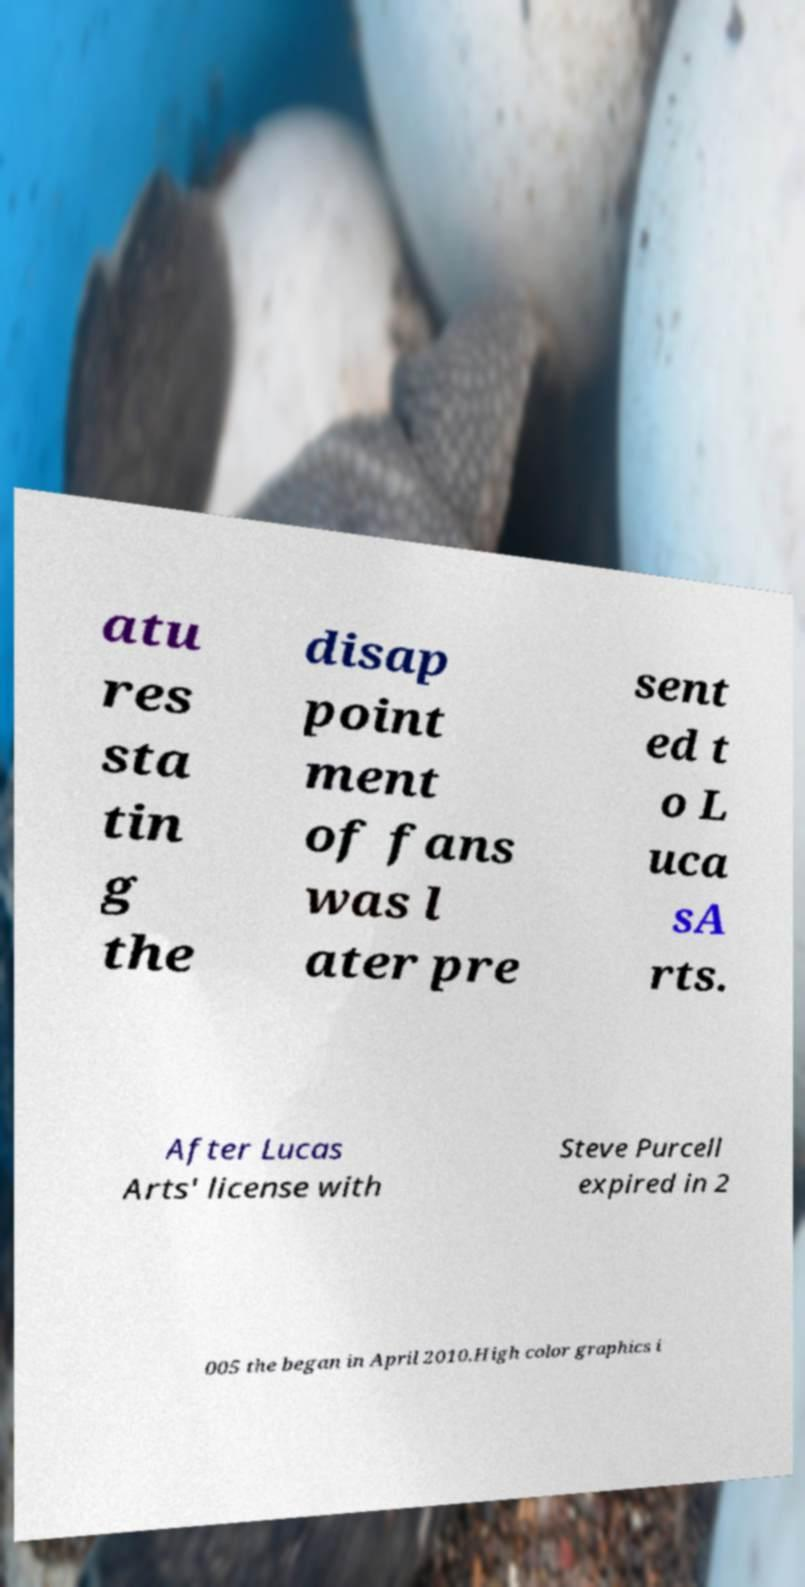There's text embedded in this image that I need extracted. Can you transcribe it verbatim? atu res sta tin g the disap point ment of fans was l ater pre sent ed t o L uca sA rts. After Lucas Arts' license with Steve Purcell expired in 2 005 the began in April 2010.High color graphics i 